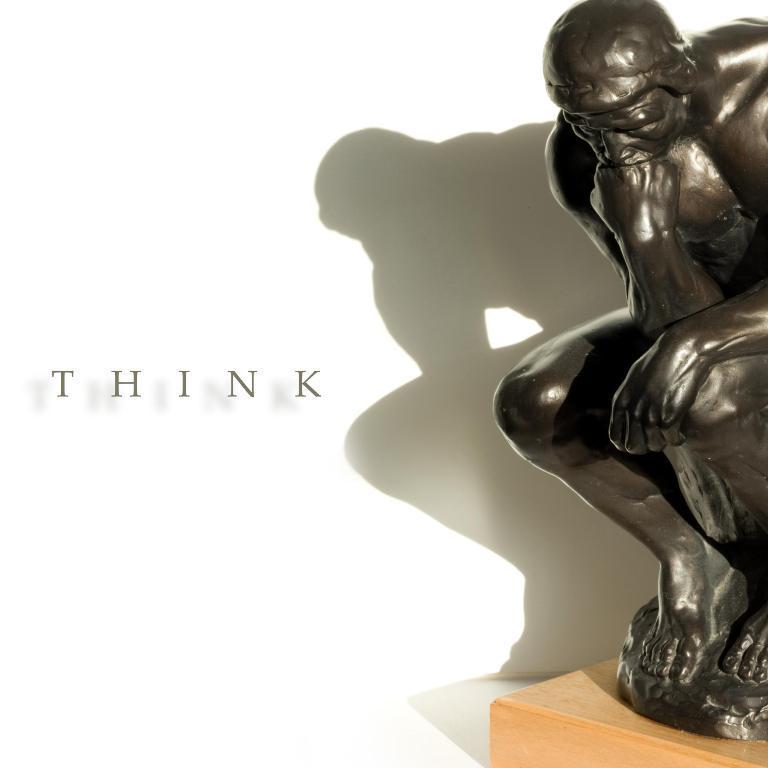Describe this image in one or two sentences. In this picture I can see a statue of a man on the table and I can see text on the left side of the picture and I can see a white color background. 